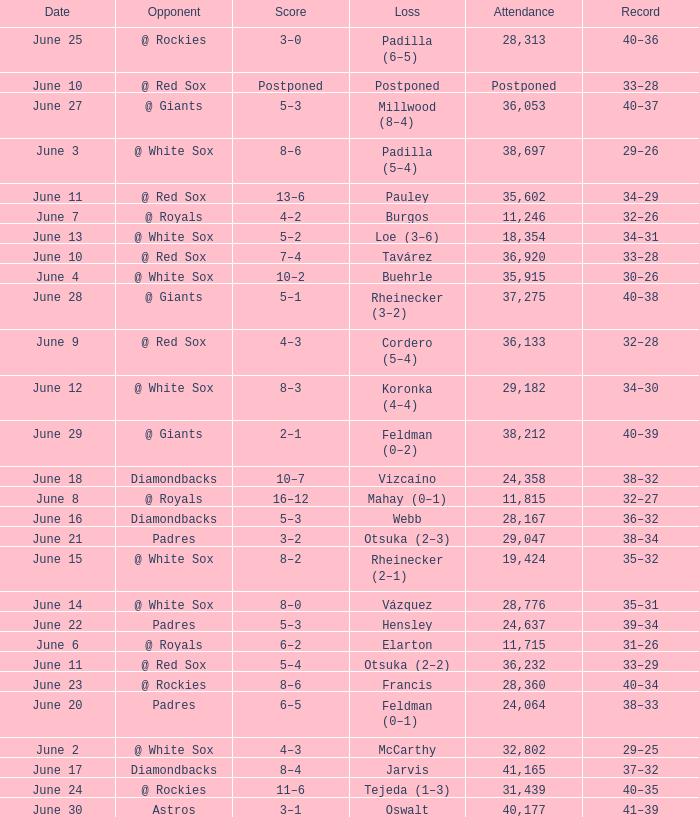When did tavárez lose? June 10. 